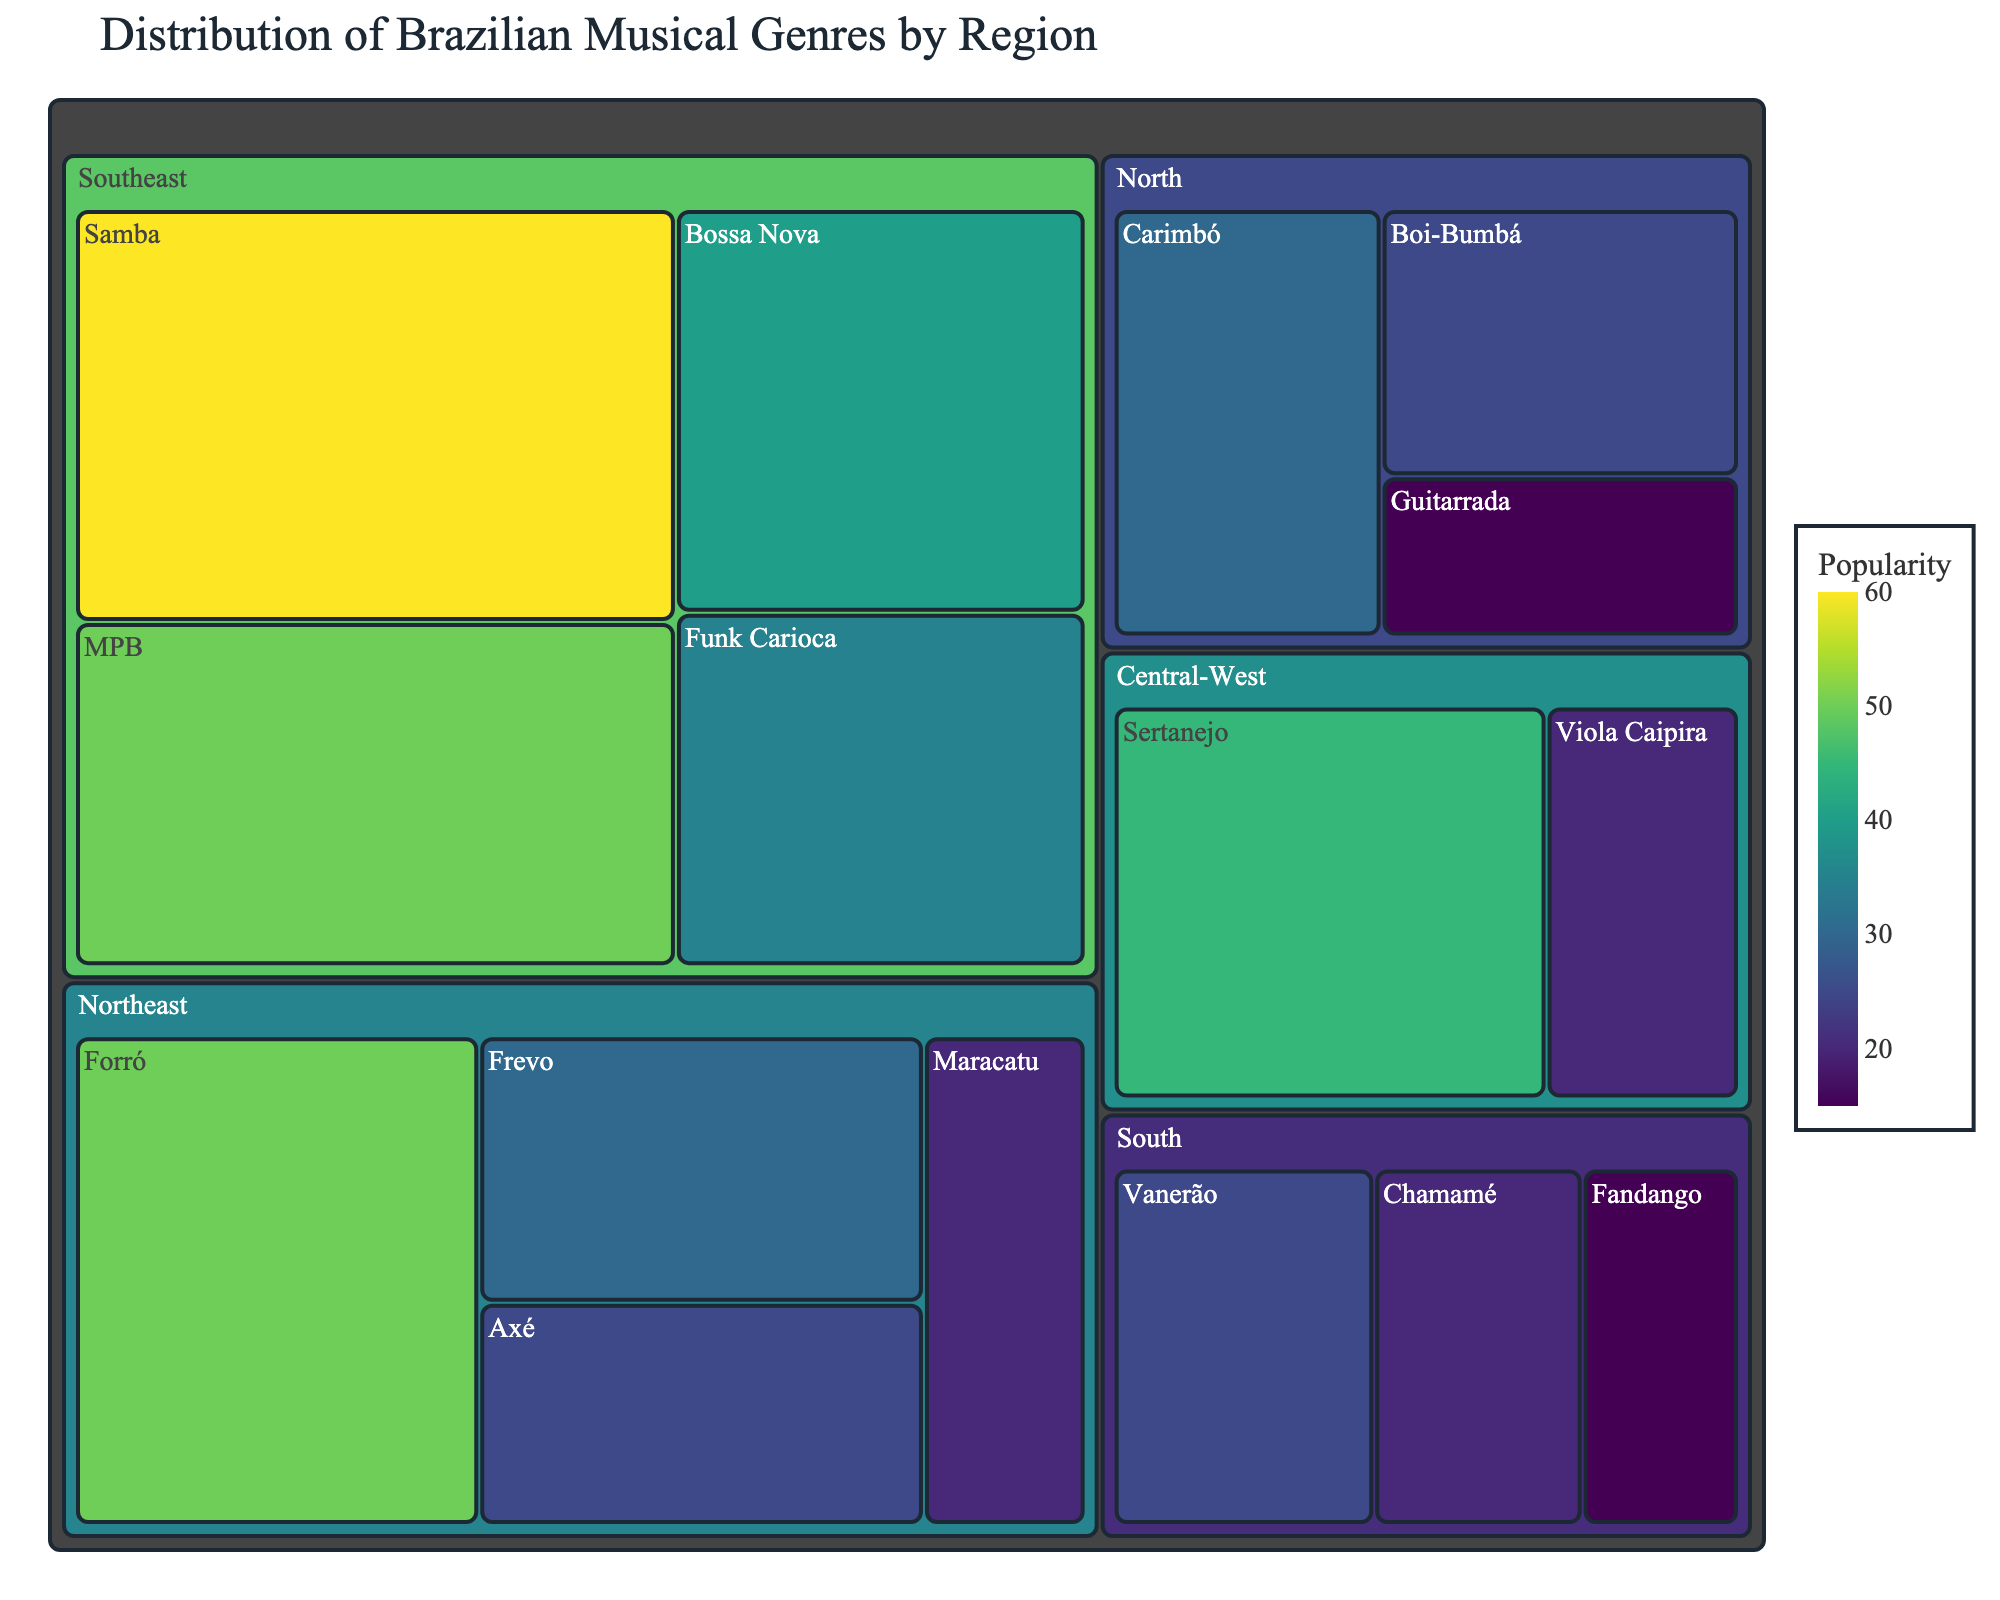What's the most popular musical genre in the Southeast region? To find the most popular genre in the Southeast, look for the genre with the highest popularity value under the Southeast section of the treemap. Samba has a popularity of 60, which is the highest in that region.
Answer: Samba Which genre has the least popularity in the North region? Scan the North section of the treemap and identify the genre with the smallest value. Guitarrada has the lowest popularity in the North region with a value of 15.
Answer: Guitarrada What total popularity does the Northeast region contribute? Sum up the popularity values of all genres in the Northeast: Forró (50) + Frevo (30) + Maracatu (20) + Axé (25) = 125.
Answer: 125 Is Carimbó more popular than Chamamé? Compare the popularity values of Carimbó (30) and Chamamé (20). Carimbó has a higher value.
Answer: Yes Which region has the highest combined popularity of musical genres? Sum the popularity values for each region and compare: North (30+25+15=70), Northeast (50+30+20+25=125), Central-West (45+20=65), Southeast (60+40+35+50=185), South (25+20+15=60). The Southeast has the highest combined popularity of 185.
Answer: Southeast What's the difference in popularity between Forró and Samba? Find the popularity values of Forró (50) and Samba (60). Subtract the smaller value from the larger: 60 - 50 = 10.
Answer: 10 Which genre in the Central-West region has the highest popularity? In the Central-West region section of the treemap, compare the values for Sertanejo (45) and Viola Caipira (20). Sertanejo has the highest popularity.
Answer: Sertanejo What is the average popularity of musical genres in the South region? To find the average popularity, sum the values for Vanerão (25), Chamamé (20), and Fandango (15), then divide by the number of genres: (25 + 20 + 15) / 3 = 20.
Answer: 20 